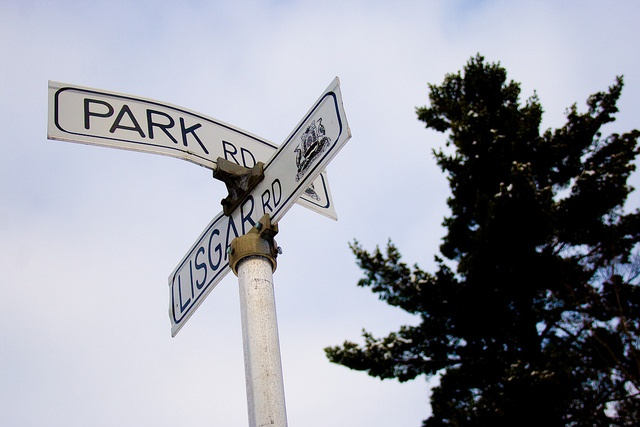Describe the objects in this image and their specific colors. I can see various objects in this image with different colors. 